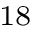Convert formula to latex. <formula><loc_0><loc_0><loc_500><loc_500>^ { 1 8 }</formula> 